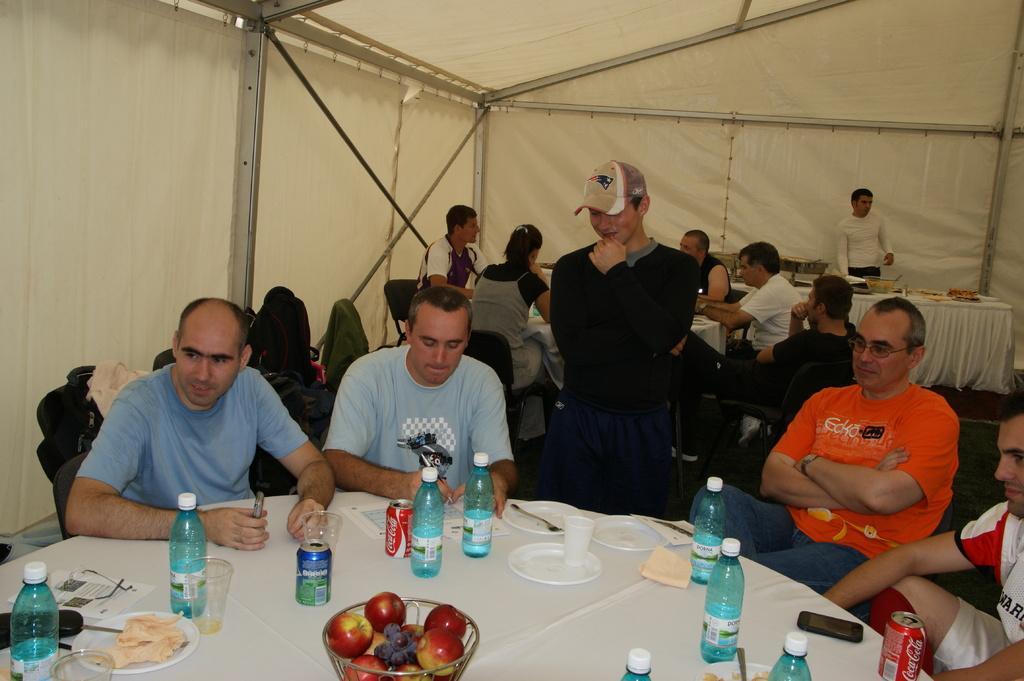In one or two sentences, can you explain what this image depicts? In this picture there are group of people those who are sitting around the tables and there is a person who is standing at the center of the image and there are different food items, water bottles, and fruits on the table and there is a white color tint around the area of the image. 